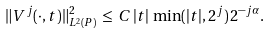<formula> <loc_0><loc_0><loc_500><loc_500>\| V ^ { j } ( \cdot , t ) \| _ { L ^ { 2 } ( P ) } ^ { 2 } \, \leq \, C \, | t | \, \min ( | t | , 2 ^ { j } ) \, 2 ^ { - j \alpha } .</formula> 